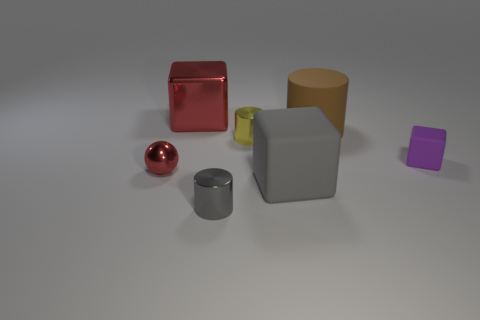Subtract all big red cubes. How many cubes are left? 2 Add 2 purple rubber cylinders. How many objects exist? 9 Subtract all spheres. How many objects are left? 6 Subtract 2 cylinders. How many cylinders are left? 1 Subtract all green cubes. Subtract all yellow spheres. How many cubes are left? 3 Subtract all yellow cylinders. How many purple blocks are left? 1 Subtract all large brown rubber objects. Subtract all tiny gray matte cylinders. How many objects are left? 6 Add 3 gray objects. How many gray objects are left? 5 Add 5 cylinders. How many cylinders exist? 8 Subtract 1 brown cylinders. How many objects are left? 6 